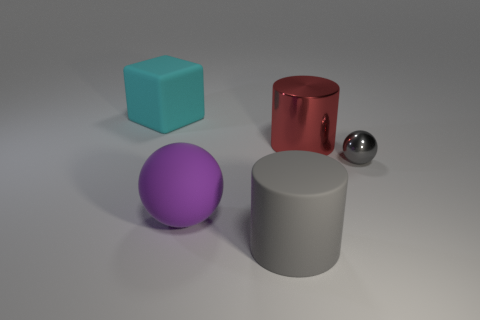Can you describe the lighting in this scene? The lighting in the scene seems diffuse and soft, with the shadows being gently cast, indicating an indirect light source. It provides a calm ambiance and allows the objects' colors and materials to be distinct and easily observable. 